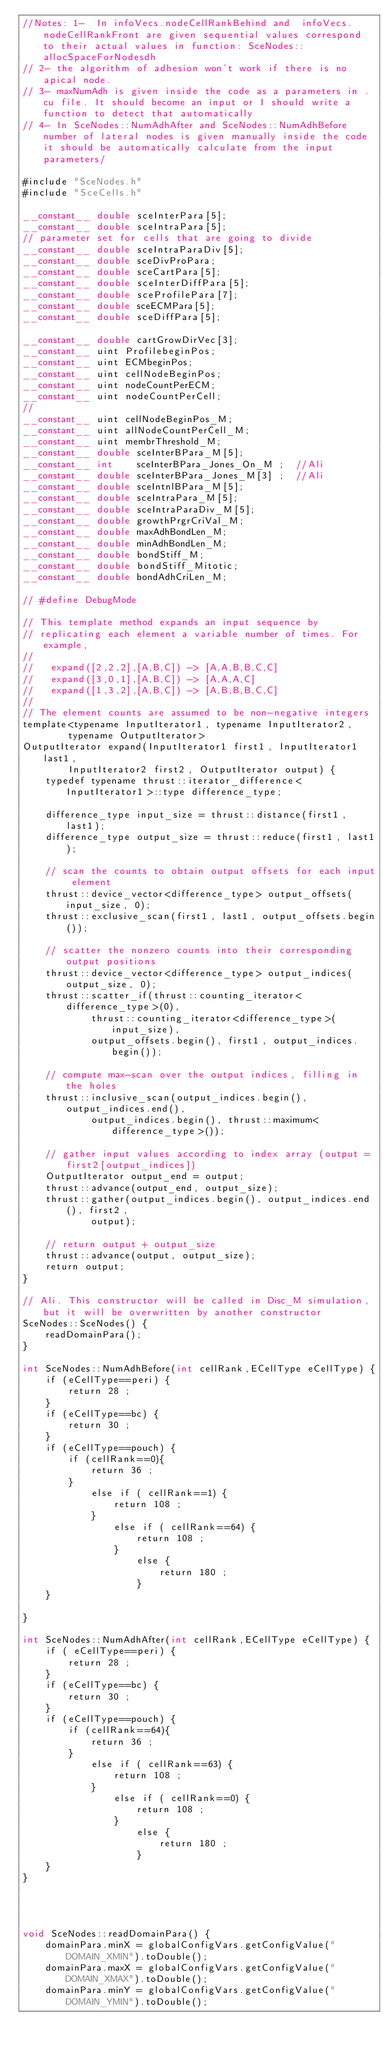<code> <loc_0><loc_0><loc_500><loc_500><_Cuda_>//Notes: 1-  In infoVecs.nodeCellRankBehind and  infoVecs.nodeCellRankFront are given sequential values correspond to their actual values in function: SceNodes::allocSpaceForNodesdh
// 2- the algorithm of adhesion won't work if there is no  apical node.
// 3- maxNumAdh is given inside the code as a parameters in .cu file. It should become an input or I should write a function to detect that automatically
// 4- In SceNodes::NumAdhAfter and SceNodes::NumAdhBefore  number of lateral nodes is given manually inside the code it should be automatically calculate from the input parameters/

#include "SceNodes.h"
#include "SceCells.h"

__constant__ double sceInterPara[5];
__constant__ double sceIntraPara[5];
// parameter set for cells that are going to divide
__constant__ double sceIntraParaDiv[5];
__constant__ double sceDivProPara;
__constant__ double sceCartPara[5];
__constant__ double sceInterDiffPara[5];
__constant__ double sceProfilePara[7];
__constant__ double sceECMPara[5];
__constant__ double sceDiffPara[5];

__constant__ double cartGrowDirVec[3];
__constant__ uint ProfilebeginPos;
__constant__ uint ECMbeginPos;
__constant__ uint cellNodeBeginPos;
__constant__ uint nodeCountPerECM;
__constant__ uint nodeCountPerCell;
//
__constant__ uint cellNodeBeginPos_M;
__constant__ uint allNodeCountPerCell_M;
__constant__ uint membrThreshold_M;
__constant__ double sceInterBPara_M[5];
__constant__ int    sceInterBPara_Jones_On_M ;  //Ali
__constant__ double sceInterBPara_Jones_M[3] ;  //Ali
__constant__ double sceIntnlBPara_M[5];
__constant__ double sceIntraPara_M[5];
__constant__ double sceIntraParaDiv_M[5];
__constant__ double growthPrgrCriVal_M;
__constant__ double maxAdhBondLen_M;
__constant__ double minAdhBondLen_M;
__constant__ double bondStiff_M;
__constant__ double bondStiff_Mitotic;
__constant__ double bondAdhCriLen_M;

// #define DebugMode

// This template method expands an input sequence by
// replicating each element a variable number of times. For example,
//
//   expand([2,2,2],[A,B,C]) -> [A,A,B,B,C,C]
//   expand([3,0,1],[A,B,C]) -> [A,A,A,C]
//   expand([1,3,2],[A,B,C]) -> [A,B,B,B,C,C]
//
// The element counts are assumed to be non-negative integers
template<typename InputIterator1, typename InputIterator2,
		typename OutputIterator>
OutputIterator expand(InputIterator1 first1, InputIterator1 last1,
		InputIterator2 first2, OutputIterator output) {
	typedef typename thrust::iterator_difference<InputIterator1>::type difference_type;

	difference_type input_size = thrust::distance(first1, last1);
	difference_type output_size = thrust::reduce(first1, last1);

	// scan the counts to obtain output offsets for each input element
	thrust::device_vector<difference_type> output_offsets(input_size, 0);
	thrust::exclusive_scan(first1, last1, output_offsets.begin());

	// scatter the nonzero counts into their corresponding output positions
	thrust::device_vector<difference_type> output_indices(output_size, 0);
	thrust::scatter_if(thrust::counting_iterator<difference_type>(0),
			thrust::counting_iterator<difference_type>(input_size),
			output_offsets.begin(), first1, output_indices.begin());

	// compute max-scan over the output indices, filling in the holes
	thrust::inclusive_scan(output_indices.begin(), output_indices.end(),
			output_indices.begin(), thrust::maximum<difference_type>());

	// gather input values according to index array (output = first2[output_indices])
	OutputIterator output_end = output;
	thrust::advance(output_end, output_size);
	thrust::gather(output_indices.begin(), output_indices.end(), first2,
			output);

	// return output + output_size
	thrust::advance(output, output_size);
	return output;
}

// Ali. This constructor will be called in Disc_M simulation, but it will be overwritten by another constructor
SceNodes::SceNodes() {
	readDomainPara();
}

int SceNodes::NumAdhBefore(int cellRank,ECellType eCellType) {
	if (eCellType==peri) {
		return 28 ; 
	}
	if (eCellType==bc) {
		return 30 ; 
	}
	if (eCellType==pouch) {
		if (cellRank==0){
			return 36 ; 
		}
			else if ( cellRank==1) {
				return 108 ; 
			}
				else if ( cellRank==64) {
					return 108 ; 					
				}
					else {
						return 180 ; 
					}
	}

}

int SceNodes::NumAdhAfter(int cellRank,ECellType eCellType) {
	if ( eCellType==peri) {
		return 28 ; 
	}
	if (eCellType==bc) {
		return 30 ; 
	}
	if (eCellType==pouch) {
		if (cellRank==64){
			return 36 ; 
		}
			else if ( cellRank==63) {
				return 108 ; 
			}
				else if ( cellRank==0) {
					return 108 ; 
				}
					else {
						return 180 ; 
					}
	}
}




void SceNodes::readDomainPara() {
	domainPara.minX = globalConfigVars.getConfigValue("DOMAIN_XMIN").toDouble();
	domainPara.maxX = globalConfigVars.getConfigValue("DOMAIN_XMAX").toDouble();
	domainPara.minY = globalConfigVars.getConfigValue("DOMAIN_YMIN").toDouble();</code> 